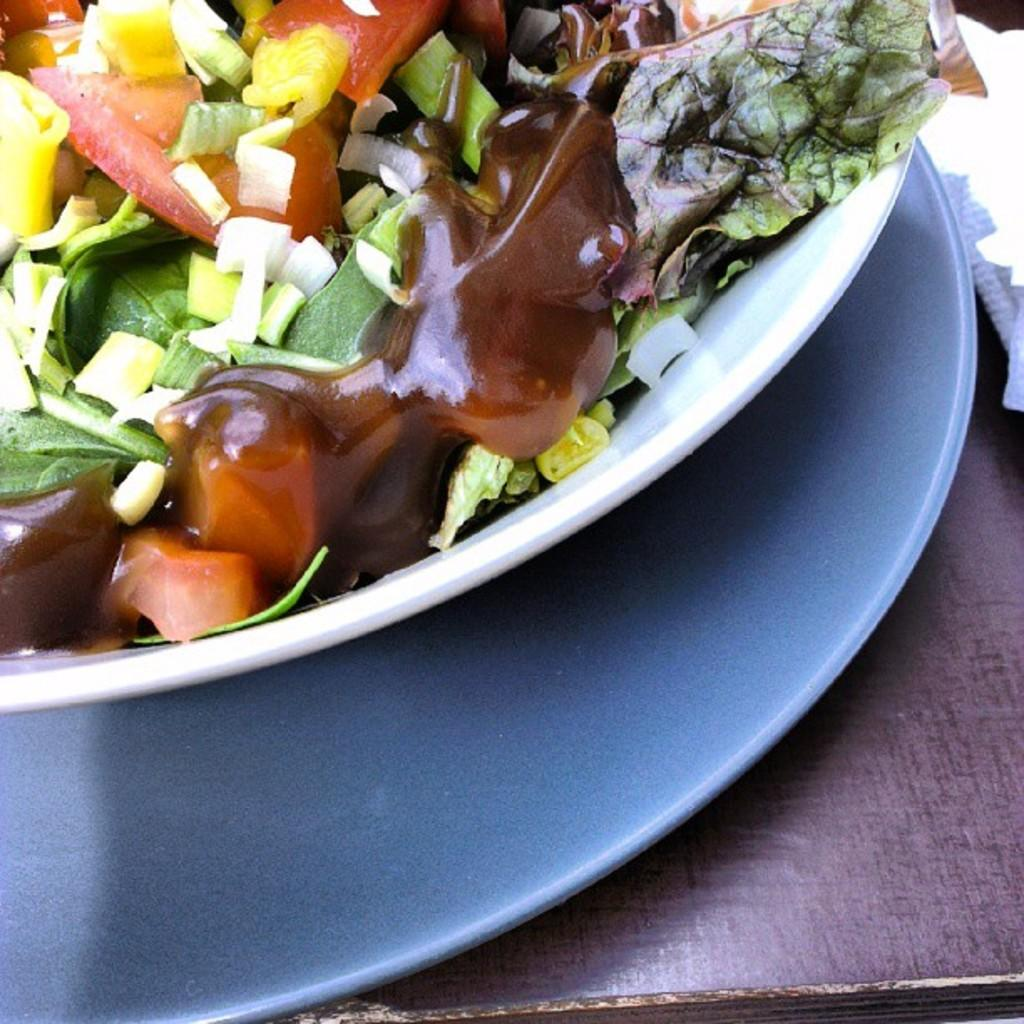What type of food can be seen in the image? There are vegetable pieces in the image. What is the color of the bowl containing the soup? The bowl is white. How is the bowl positioned in relation to the plate? The bowl is placed on a plate. What type of table is the plate and bowl placed on? The plate and bowl are placed on a wooden table. What is the color of the paper on the wooden table? The paper is white. What direction is the society moving in the image? There is no society present in the image, so it is not possible to determine the direction it is moving in. 